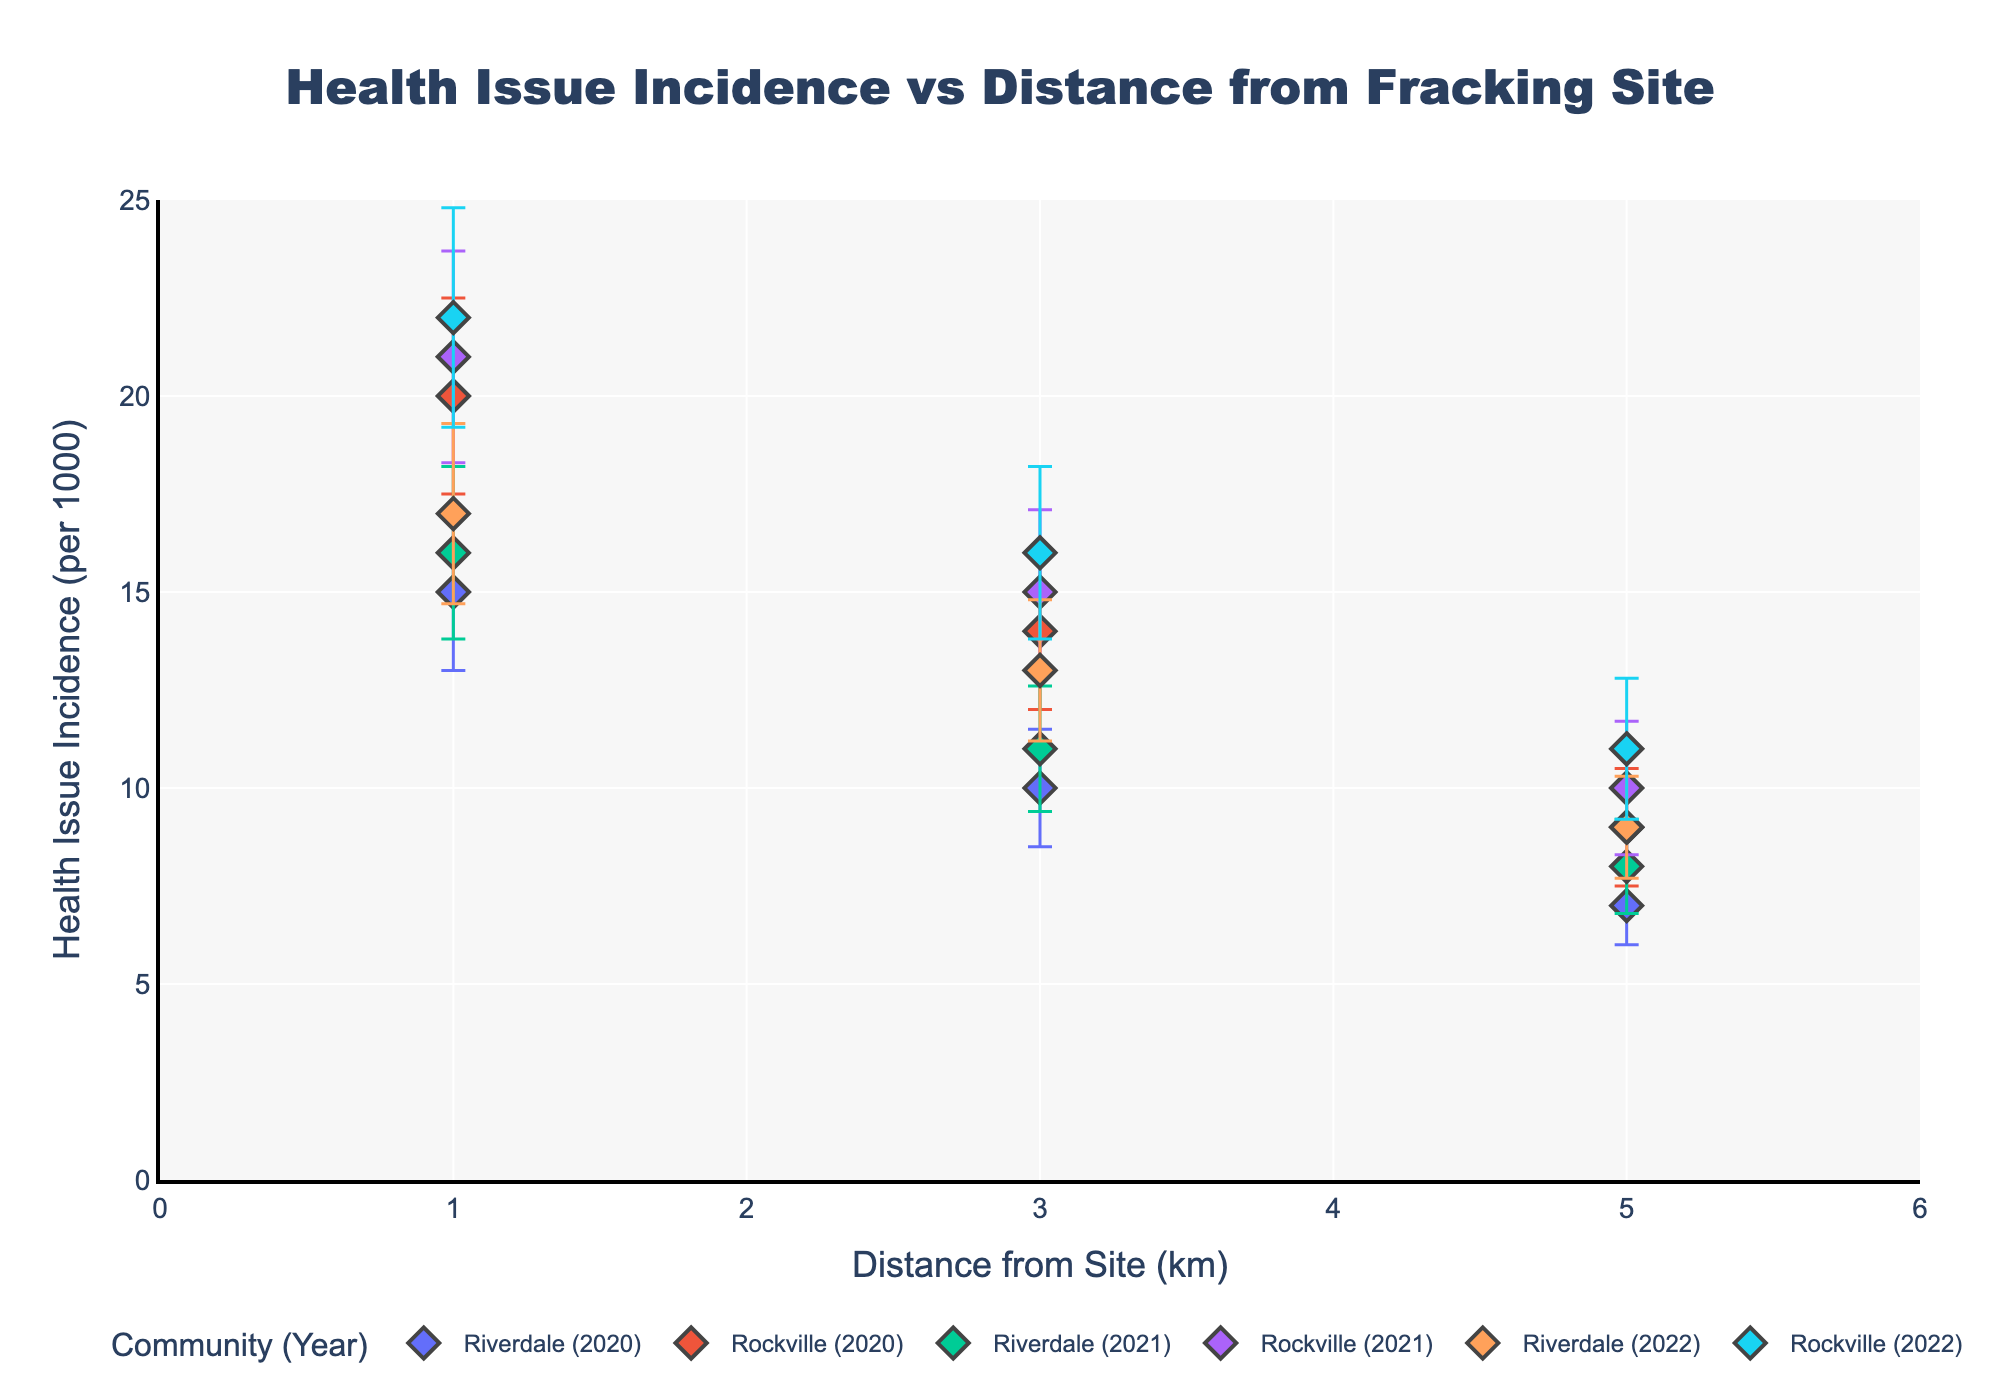what is the title of the figure? The title is located at the top of the figure, usually in a larger font. It provides a high-level overview of what the figure represents. In this case, the figure's title is "Health Issue Incidence vs Distance from Fracking Site".
Answer: Health Issue Incidence vs Distance from Fracking Site How many distinct communities are presented in the plot? By looking at the legend, which indicates different groups and their respective markers, you can identify that there are two distinct communities: Riverdale and Rockville.
Answer: 2 What is the range of the x-axis? The x-axis range is specified along the horizontal line of the plot, showing the distance in kilometers from the fracking site. The x-axis spans from 0 to 6 kilometers.
Answer: 0 to 6 Which year demonstrates the highest health issue incidence at 1 km distance in Rockville? By referring to the data points for Rockville and observing the error bars and markers, you can identify that the year 2022 shows the highest health issue incidence at 1 km with a rate of 22 per 1000.
Answer: 2022 What is the standard error for Riverdale’s health issue incidence in 2021 at 3 km? By looking at the error bars for Riverdale in 2021 at the 3 km distance marker, you can see that the standard error is 1.6.
Answer: 1.6 What is the difference in health issue incidence between Riverdale and Rockville in 2021 at 5 km? Locate the 2021 data points for both Riverdale and Rockville at the 5 km distance. Riverdale shows an incidence of 8 per 1000, while Rockville shows 10 per 1000. The difference is 10 - 8.
Answer: 2 Which community shows a consistent increase in health issue incidence from 2020 to 2022 at 3 km distance? Look at the data points for each year (2020, 2021, 2022) at the 3 km distance for both communities. Riverdale shows an upward trend from 10 to 11 to 13, indicating a consistent increase.
Answer: Riverdale What is the average health issue incidence for Rockville across all years at 1 km? Sum the health issue incidences for Rockville at 1 km for each year (20 in 2020, 21 in 2021, 22 in 2022) and divide by the number of years (3). (20 + 21 + 22) / 3 = 21.
Answer: 21 Do any years show overlapping error bars for Riverdale and Rockville at 3 km? Examine the error bars at the 3 km distance in all years for both communities. If the error bars intersect, they are overlapping.  For both years 2020 and 2021, the error bars for Riverdale and Rockville at 3 km do overlap.
Answer: Yes Are there any outliers in the health issue incidence for any year-community combinations that deviate significantly from nearby distances? This would involve scanning all points and their error bars to see if there are any data points that significantly deviated from the others at nearby distances. No single point deviates significantly from the trend within its community and year group.
Answer: No 